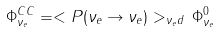<formula> <loc_0><loc_0><loc_500><loc_500>\Phi _ { \nu _ { e } } ^ { C C } = < P ( \nu _ { e } \to \nu _ { e } ) > _ { \nu _ { e } d } \, \Phi _ { \nu _ { e } } ^ { 0 }</formula> 